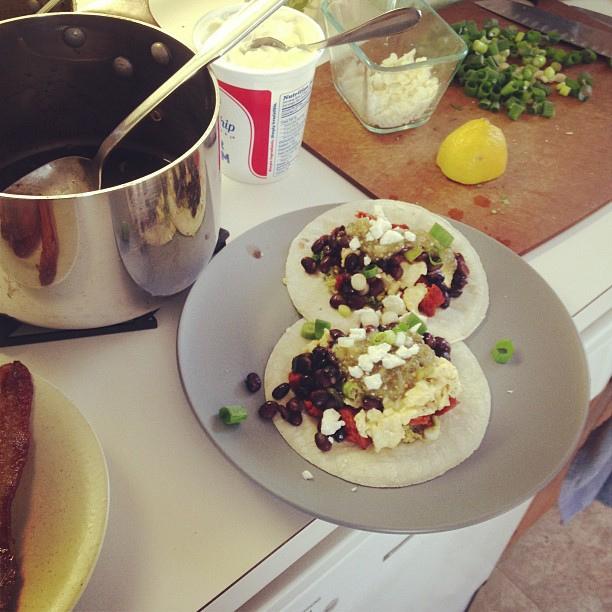What is the metal cooking utensil?
Give a very brief answer. Spoon. Would a vegan eat this?
Give a very brief answer. Yes. Is there two spoons in this picture?
Short answer required. Yes. What is the yellow food?
Concise answer only. Lemon. Do you see a drink?
Short answer required. No. What color is the plate?
Give a very brief answer. White. What color plate is being used?
Short answer required. White. What is this person having with their pizza that is more healthy?
Concise answer only. Vegetables. Where is the spoon?
Be succinct. In pot. IS this a formal or home cooked meal?
Concise answer only. Home cooked. What is the white bits on the food?
Answer briefly. Cheese. Are the plates on the table?
Quick response, please. Yes. What are the small blue items?
Quick response, please. Beans. 